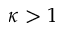Convert formula to latex. <formula><loc_0><loc_0><loc_500><loc_500>\kappa > 1</formula> 